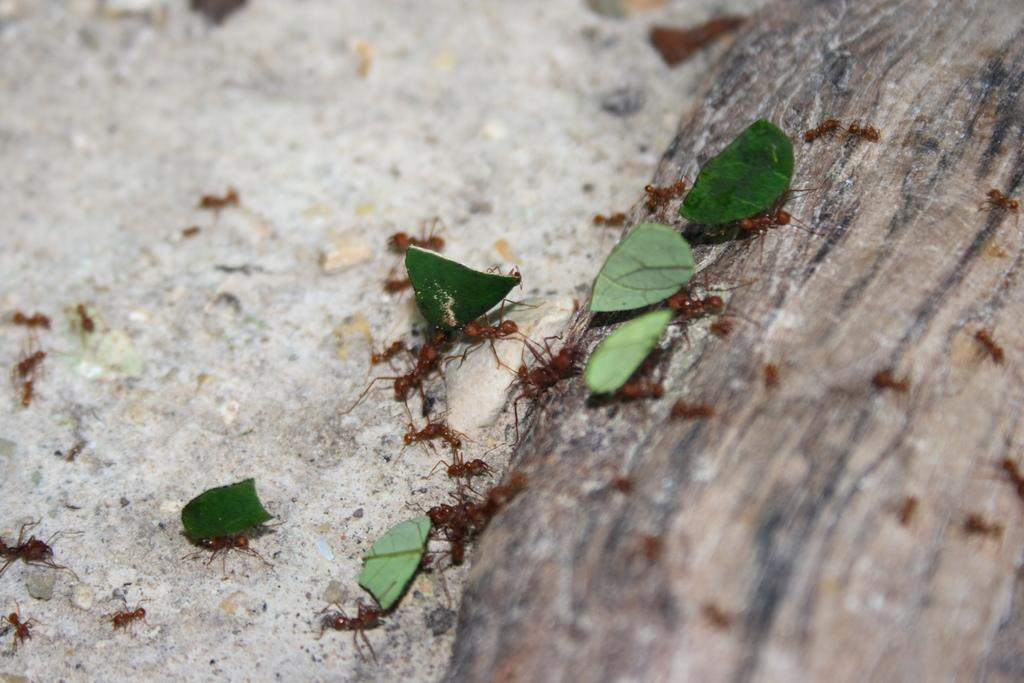What type of insects are present in the image? There are red ants in the image. What can be seen on the surface in the image? There are leaves on a surface in the image. How many houses are depicted in the image? There are no houses present in the image; it features red ants and leaves on a surface. What type of cast is visible in the image? There is no cast present in the image. 